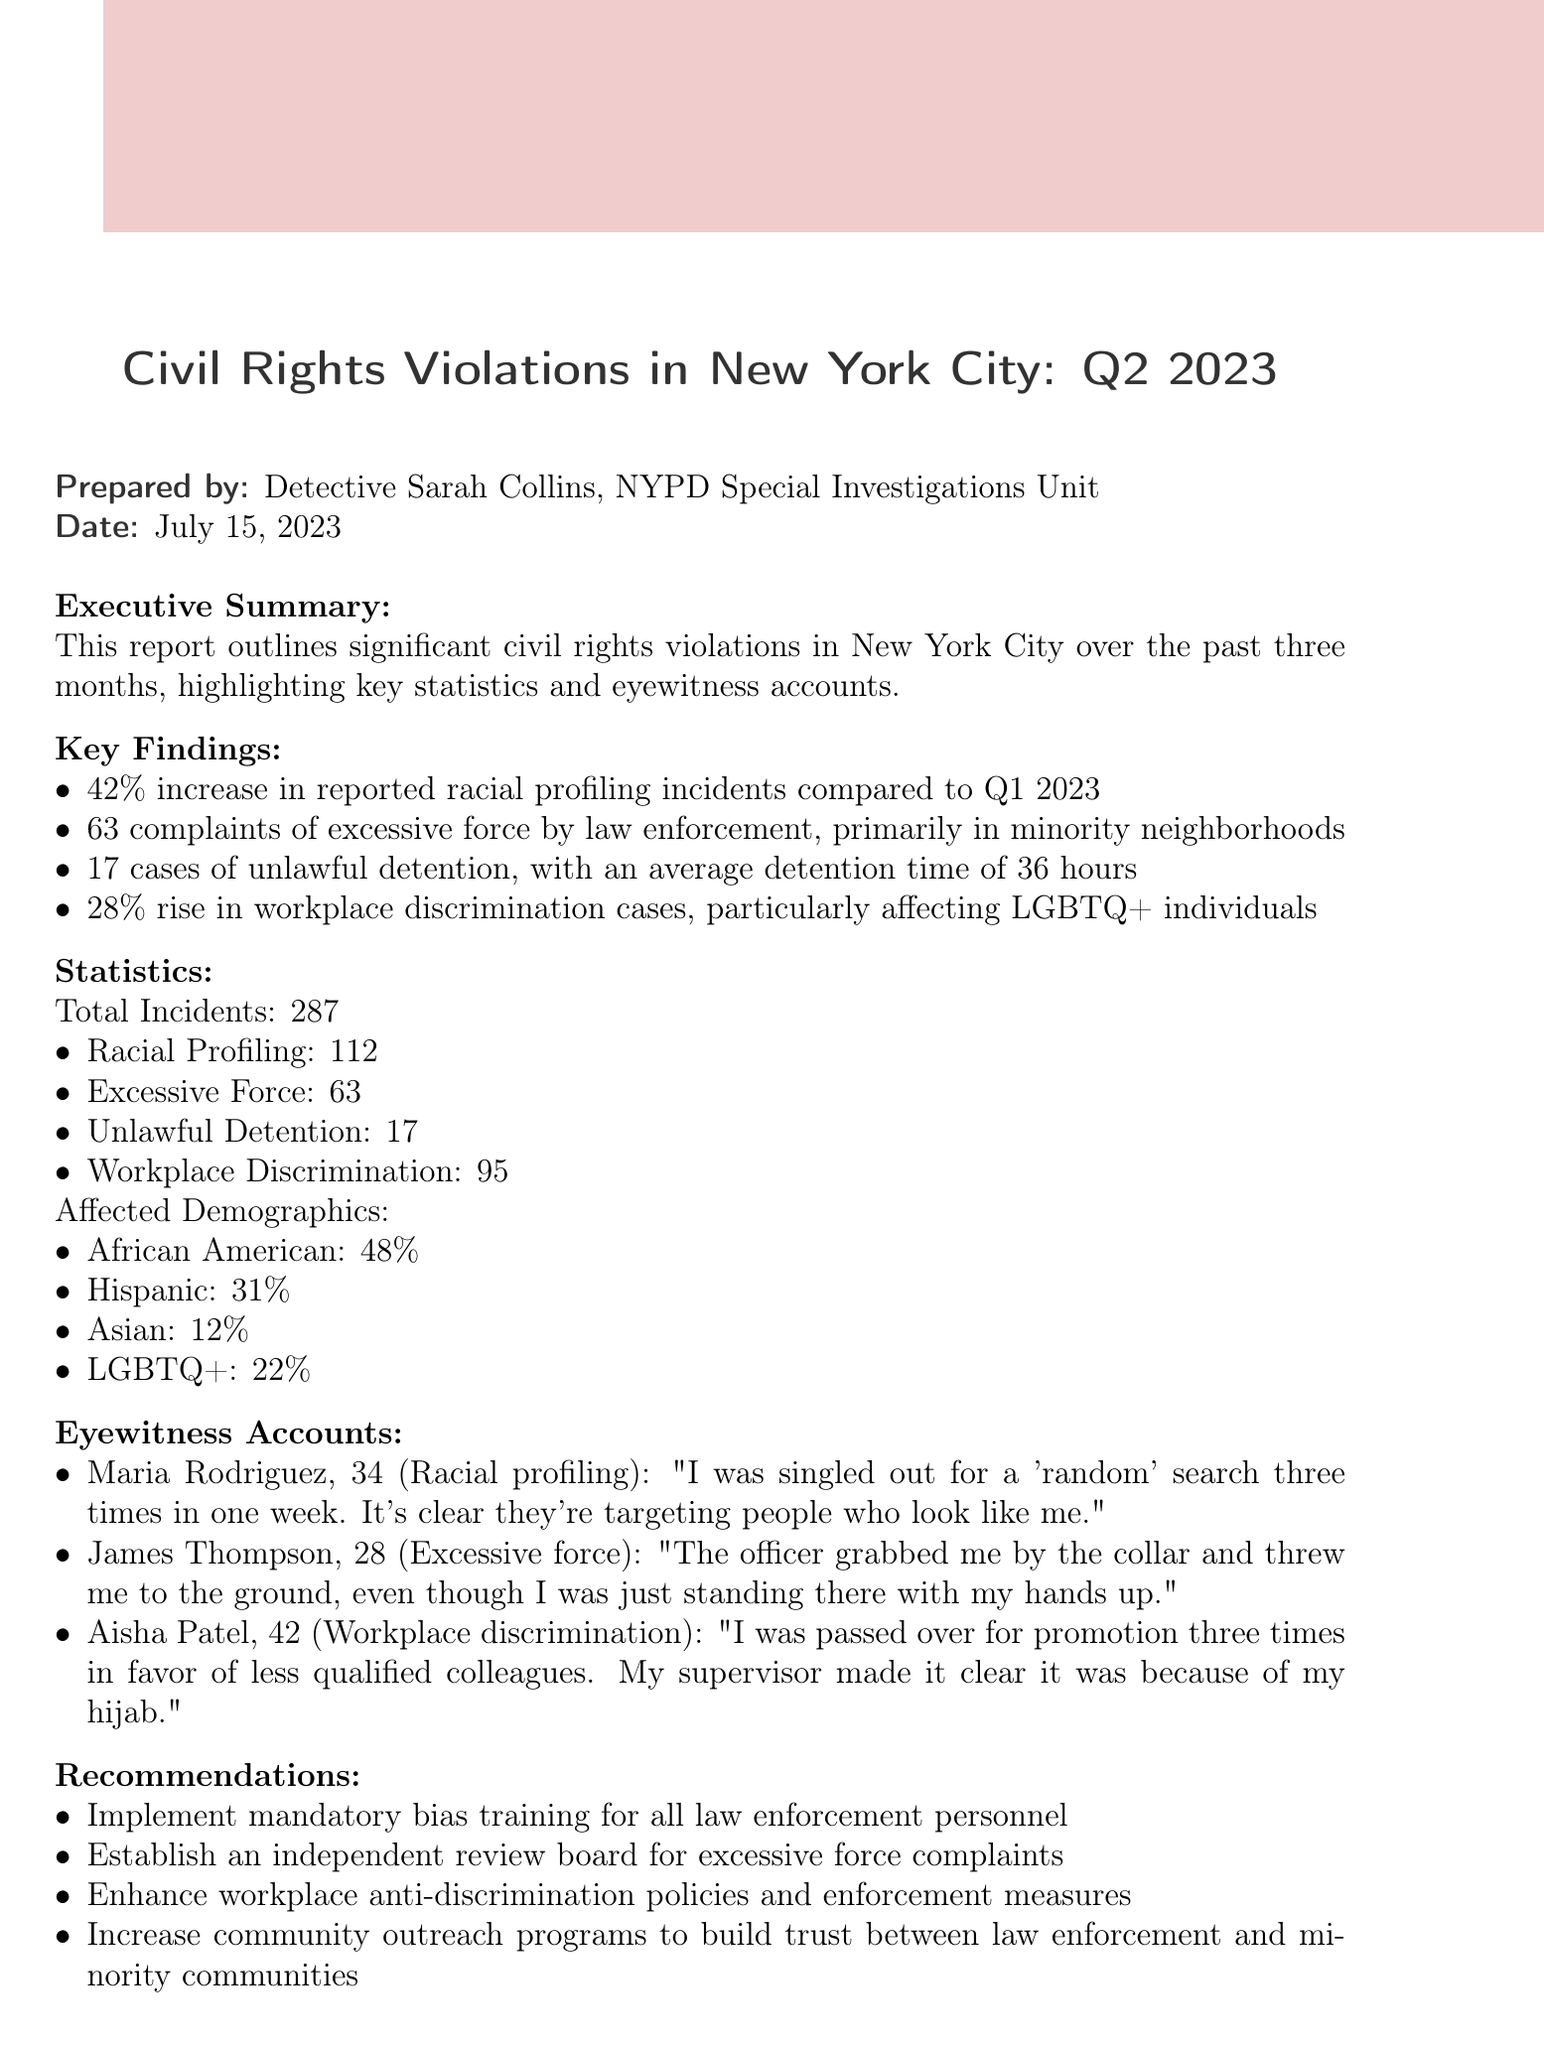what is the report title? The report title is mentioned at the beginning of the document under the header section.
Answer: Civil Rights Violations in New York City: Q2 2023 who prepared the report? The name of the person who prepared the report is stated in the header section.
Answer: Detective Sarah Collins what is the total number of incidents reported? The total number of incidents is listed in the statistics section of the document.
Answer: 287 how many complaints of excessive force were reported? The specific number of complaints of excessive force is provided in the key findings.
Answer: 63 which demographic has the highest percentage of civil rights violations? The percentages for different demographics are listed in the statistics section, showing which group has the highest representation.
Answer: African American what is the average detention time for unlawful detention cases? The average time is mentioned in the key findings and provides context for the unlawful detention cases.
Answer: 36 hours what is one of the recommendations made in the report? Recommendations are provided at the end of the document, giving proposed actions in response to the findings.
Answer: Implement mandatory bias training for all law enforcement personnel what percentage increase in workplace discrimination cases was observed? The percentage increase is noted in the key findings, indicating the change in workplace discrimination.
Answer: 28% who witnessed racial profiling at a subway station? Eyewitness accounts list specific individuals and their experiences related to civil rights violations.
Answer: Maria Rodriguez 